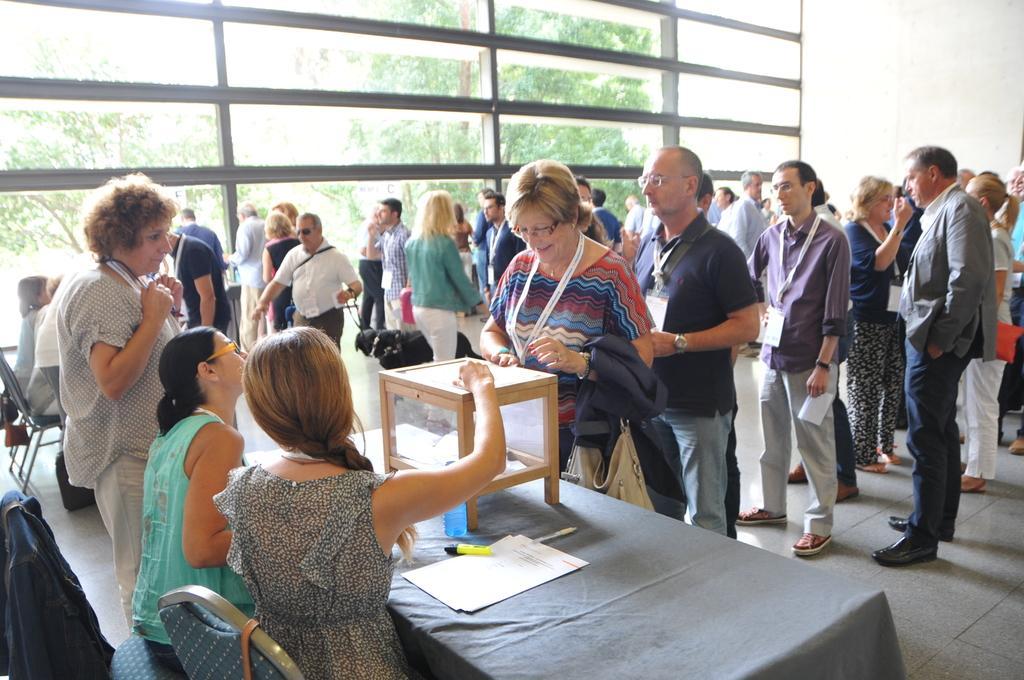Can you describe this image briefly? In this picture group of people standing. These four persons are sitting on the chair. There is a table. On the table we can see box,paper,sketch,bottle. There is a glass. From this class we can see trees. This is floor. On the background we can see wall. 